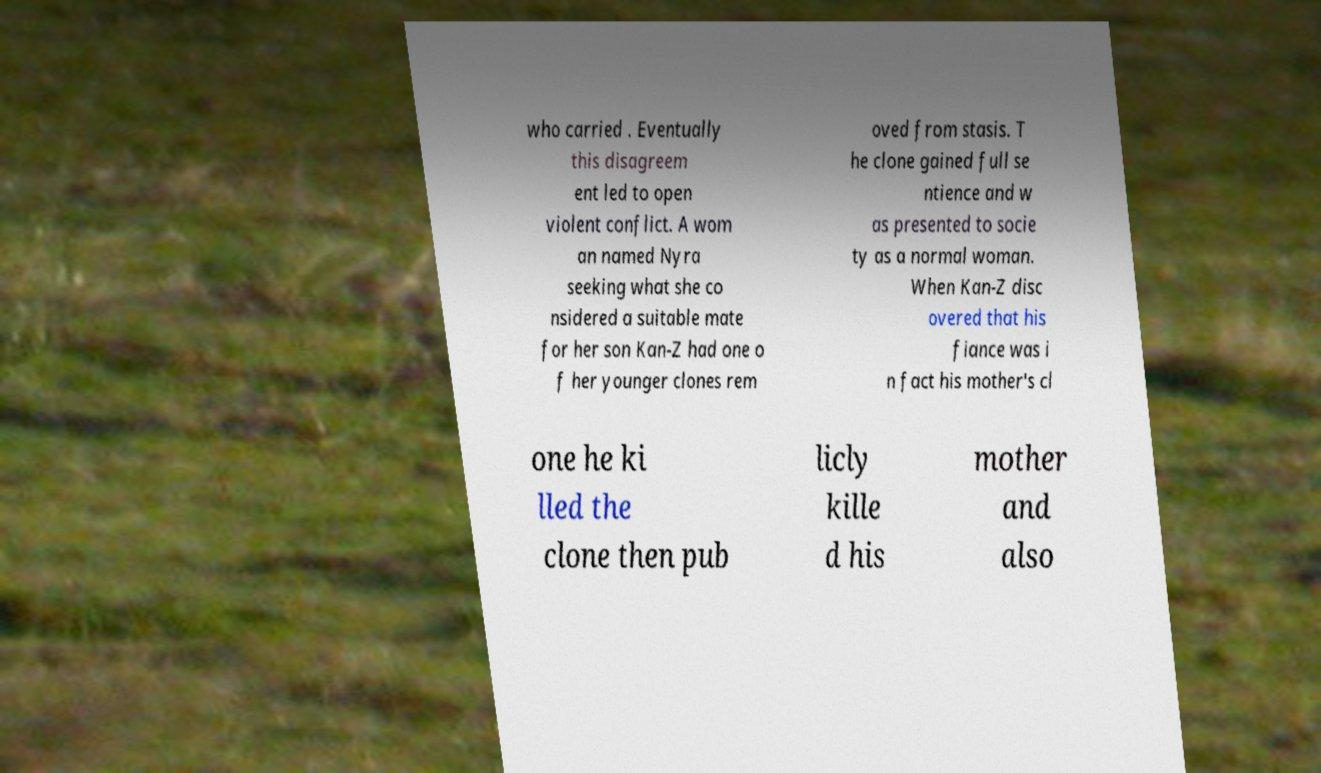For documentation purposes, I need the text within this image transcribed. Could you provide that? who carried . Eventually this disagreem ent led to open violent conflict. A wom an named Nyra seeking what she co nsidered a suitable mate for her son Kan-Z had one o f her younger clones rem oved from stasis. T he clone gained full se ntience and w as presented to socie ty as a normal woman. When Kan-Z disc overed that his fiance was i n fact his mother's cl one he ki lled the clone then pub licly kille d his mother and also 